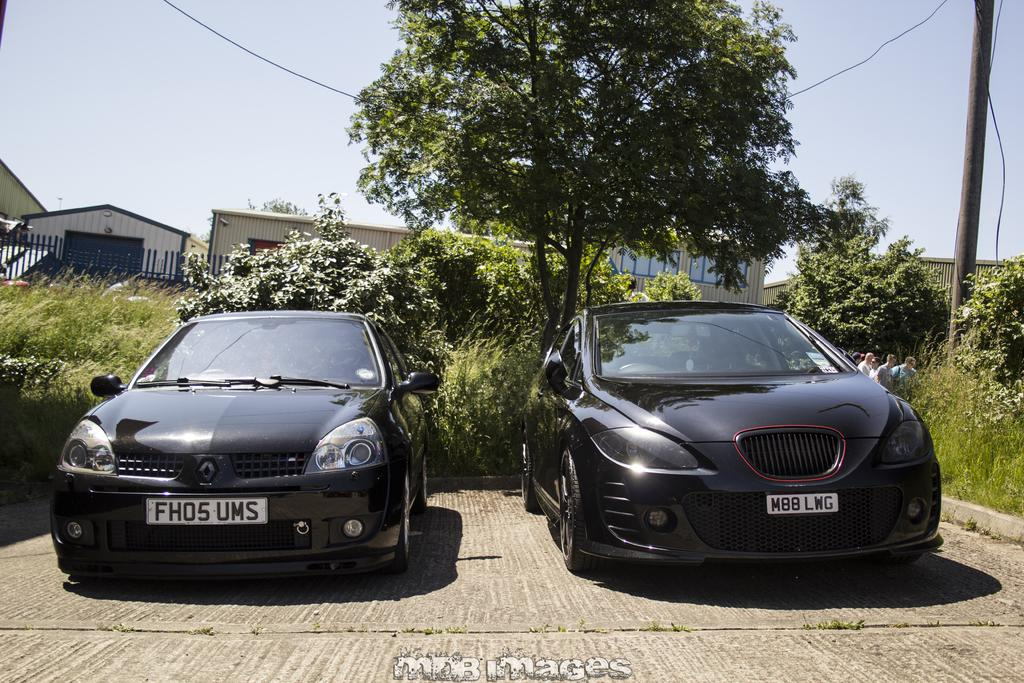What type of structures can be seen in the image? There are houses in the image. What natural elements are present in the image? There are trees and plants in the image. What man-made feature separates the houses and trees? There is a fence in the image. What vehicles can be seen in the image? There are cars in the image. What part of the natural environment is visible in the image? The sky is visible in the image. What time of day is it in the image, and what is the depicted person doing to get attention? There is no person present in the image, so it is not possible to determine what they might be doing to get attention. Additionally, the time of day cannot be determined from the image. 